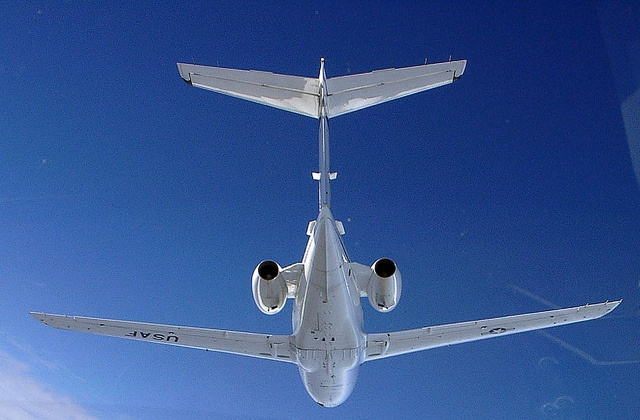Describe the objects in this image and their specific colors. I can see a airplane in darkblue, darkgray, and gray tones in this image. 